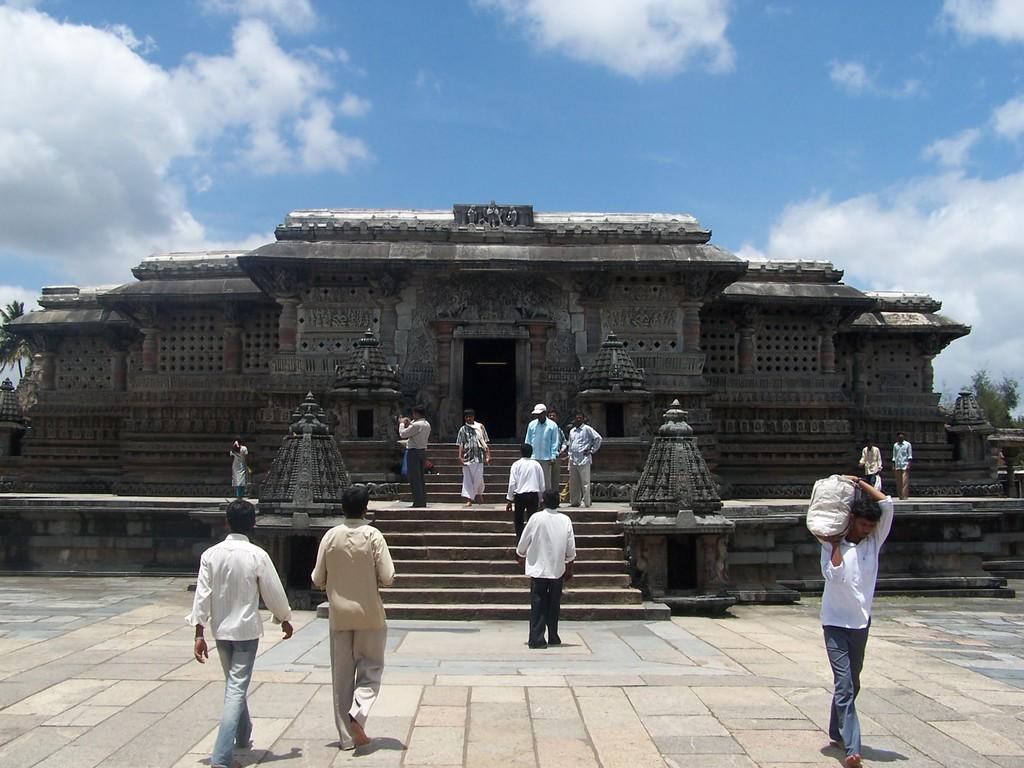In one or two sentences, can you explain what this image depicts? In this image we can see stairs, persons, temple, trees, sky and clouds. 